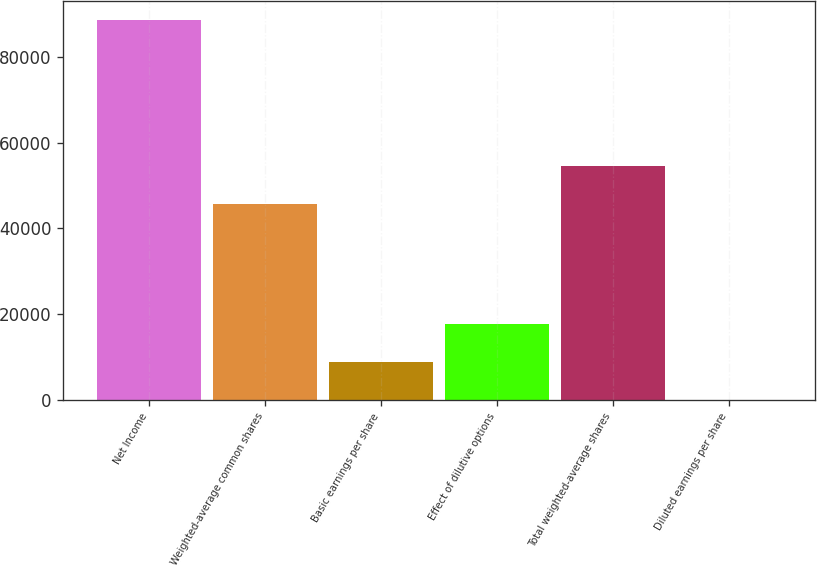<chart> <loc_0><loc_0><loc_500><loc_500><bar_chart><fcel>Net Income<fcel>Weighted-average common shares<fcel>Basic earnings per share<fcel>Effect of dilutive options<fcel>Total weighted-average shares<fcel>Diluted earnings per share<nl><fcel>88645<fcel>45630<fcel>8866.15<fcel>17730.5<fcel>54494.3<fcel>1.83<nl></chart> 